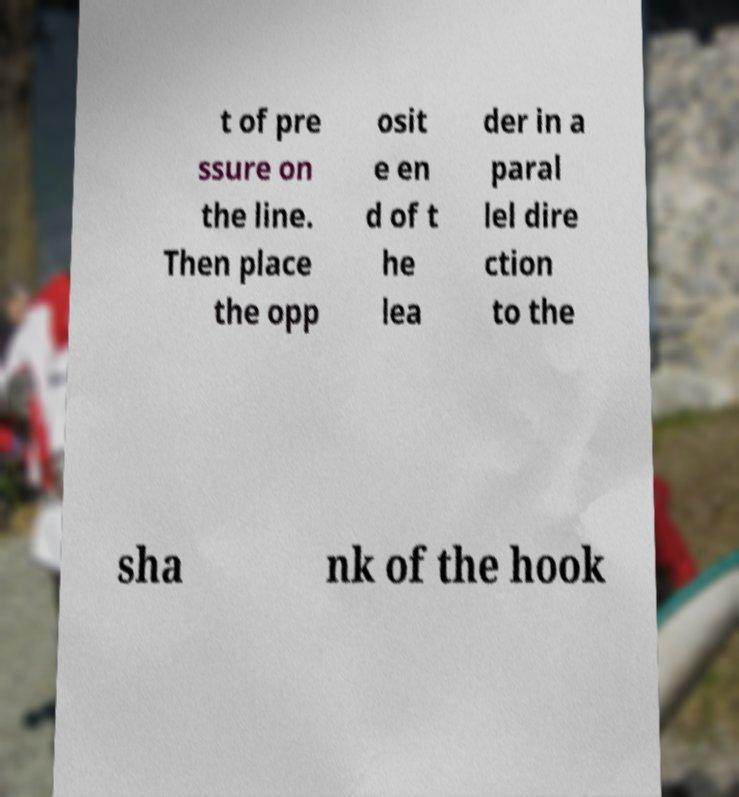There's text embedded in this image that I need extracted. Can you transcribe it verbatim? t of pre ssure on the line. Then place the opp osit e en d of t he lea der in a paral lel dire ction to the sha nk of the hook 